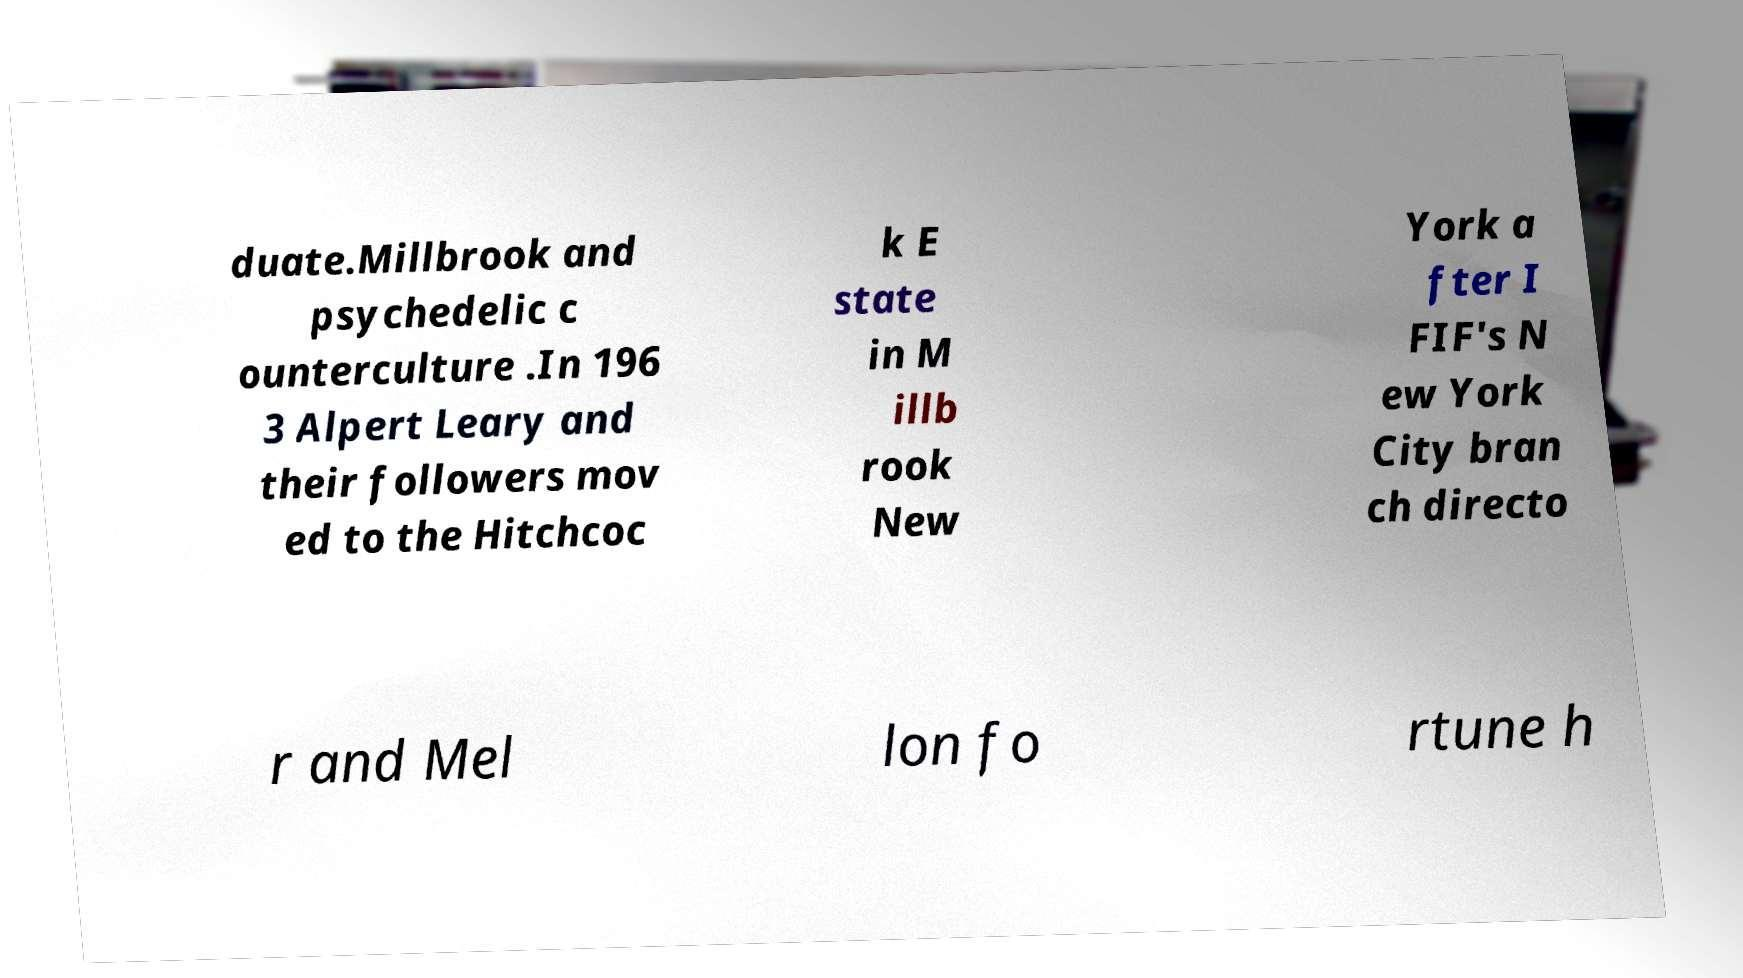There's text embedded in this image that I need extracted. Can you transcribe it verbatim? duate.Millbrook and psychedelic c ounterculture .In 196 3 Alpert Leary and their followers mov ed to the Hitchcoc k E state in M illb rook New York a fter I FIF's N ew York City bran ch directo r and Mel lon fo rtune h 